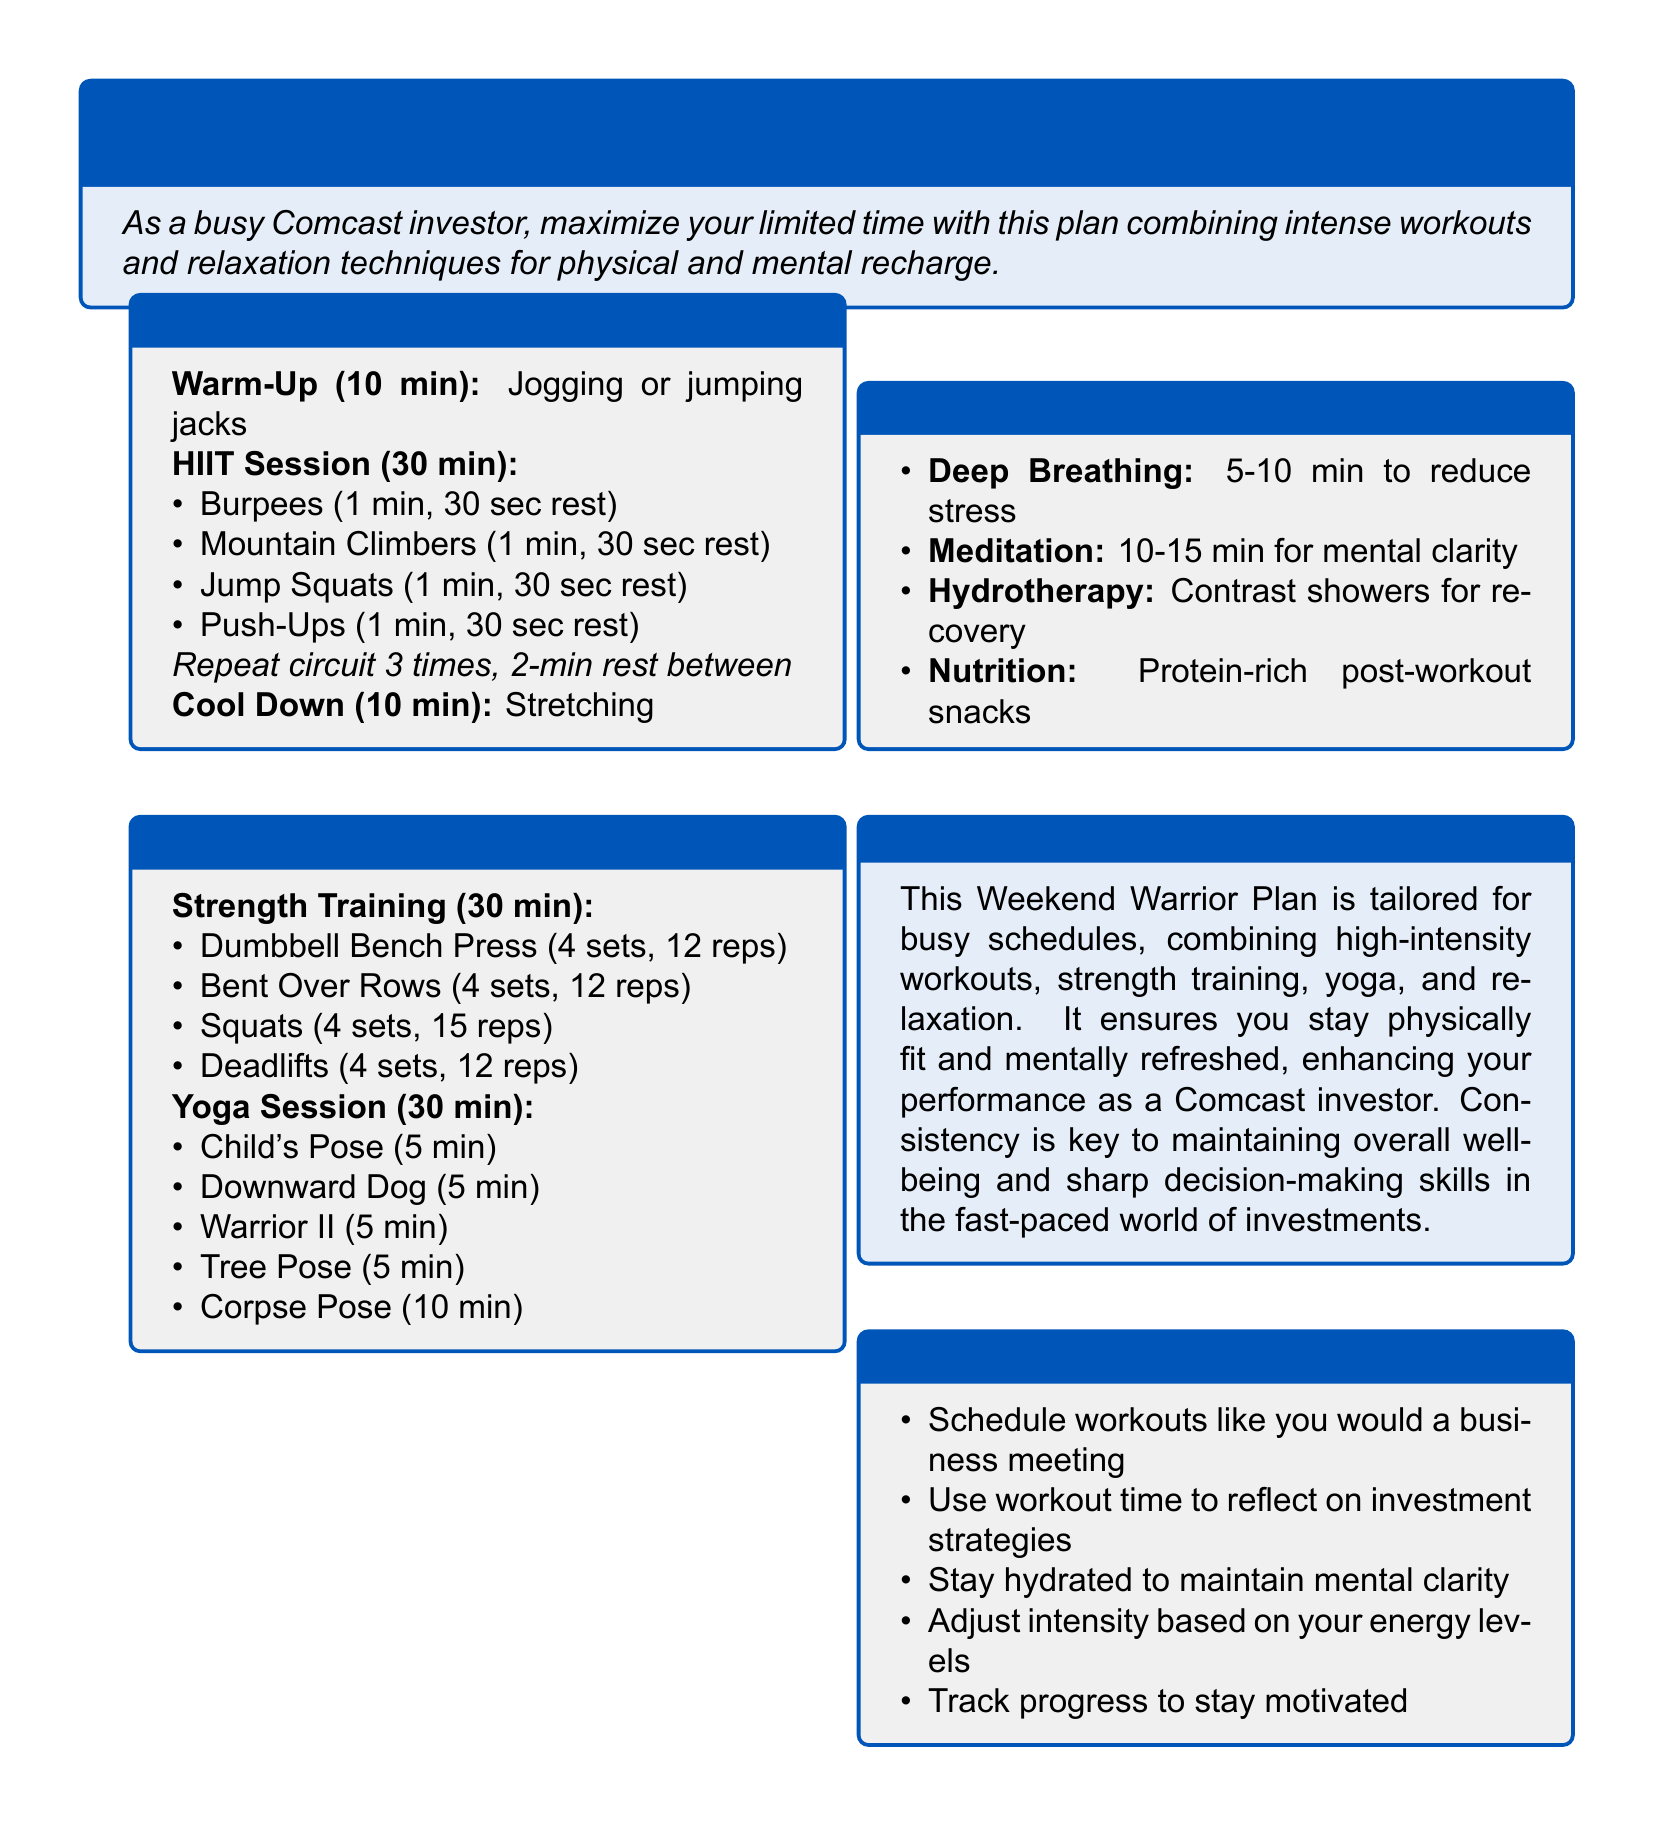What is the duration of the HIIT session? The HIIT session is 30 minutes long, as stated in the Saturday section.
Answer: 30 min How many sets are suggested for the Dumbbell Bench Press? The document specifies 4 sets for the Dumbbell Bench Press in the Sunday section.
Answer: 4 sets What is a recommended post-workout snack? The document recommends a protein-rich post-workout snack under the Nutrition section.
Answer: Protein-rich snacks What relaxation technique involves 5-10 minutes? The Deep Breathing technique is suggested for 5-10 minutes to reduce stress.
Answer: Deep Breathing How many reps are recommended for Squats? The document indicates 15 reps for Squats in the Strength Training section on Sunday.
Answer: 15 reps What is the total duration of the Yoga session? The Yoga session is detailed to last for 30 minutes in the Sunday section.
Answer: 30 min Which activity is performed for 10 minutes in the Yoga session? The last activity listed is the Corpse Pose, which is performed for 10 minutes.
Answer: Corpse Pose What should you adjust based on energy levels? The document suggests to adjust intensity based on your energy levels for workouts.
Answer: Intensity How many times should the HIIT circuit be repeated? The HIIT circuit should be repeated 3 times as noted in the Saturday section.
Answer: 3 times 